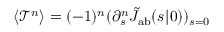Convert formula to latex. <formula><loc_0><loc_0><loc_500><loc_500>\langle \mathcal { T } ^ { n } \rangle = ( - 1 ) ^ { n } ( \partial _ { s } ^ { n } \tilde { J } _ { a b } ( s | \ r _ { 0 } ) ) _ { s = 0 }</formula> 